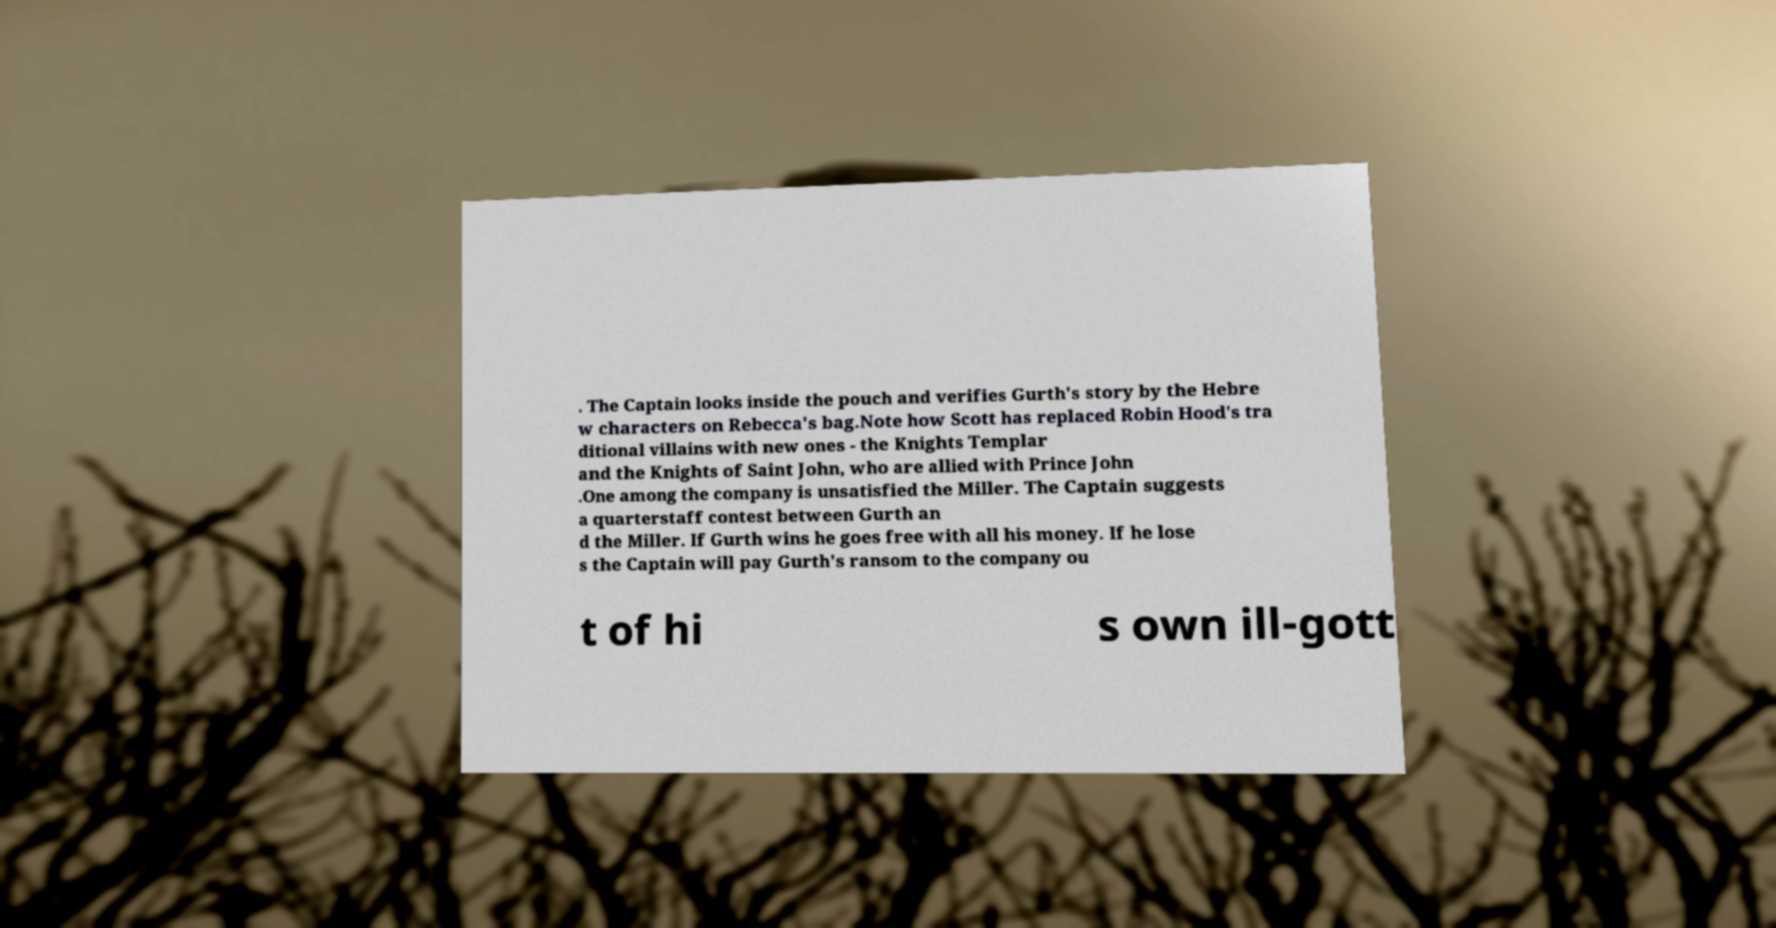What messages or text are displayed in this image? I need them in a readable, typed format. . The Captain looks inside the pouch and verifies Gurth's story by the Hebre w characters on Rebecca's bag.Note how Scott has replaced Robin Hood's tra ditional villains with new ones - the Knights Templar and the Knights of Saint John, who are allied with Prince John .One among the company is unsatisfied the Miller. The Captain suggests a quarterstaff contest between Gurth an d the Miller. If Gurth wins he goes free with all his money. If he lose s the Captain will pay Gurth's ransom to the company ou t of hi s own ill-gott 